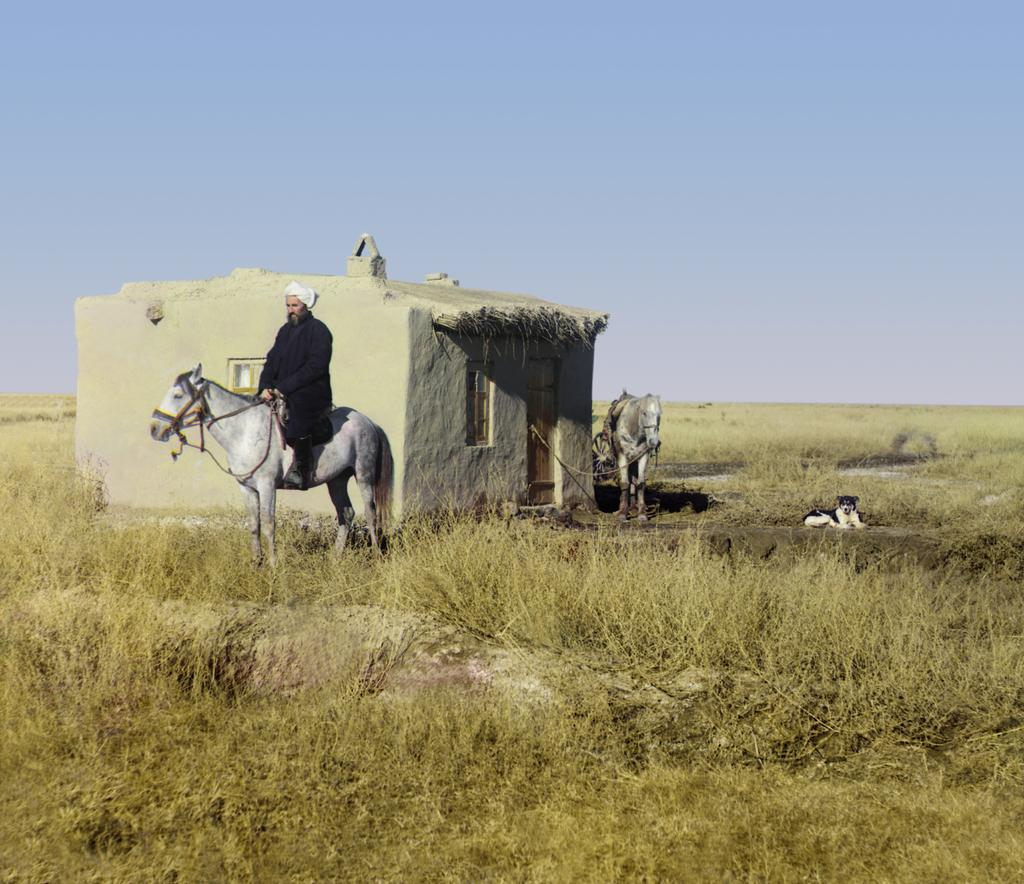What type of building is visible in the image? There is a house with windows in the image. What animals are present in the image? There are two horses and a dog in the image. Who is riding one of the horses? A man is sitting on one of the horses. What can be seen in the background of the image? The sky is visible in the background of the image. Can you hear the song that the fairies are singing in the image? There are no fairies or songs present in the image. Is the goat grazing in the background of the image? There is no goat present in the image. 